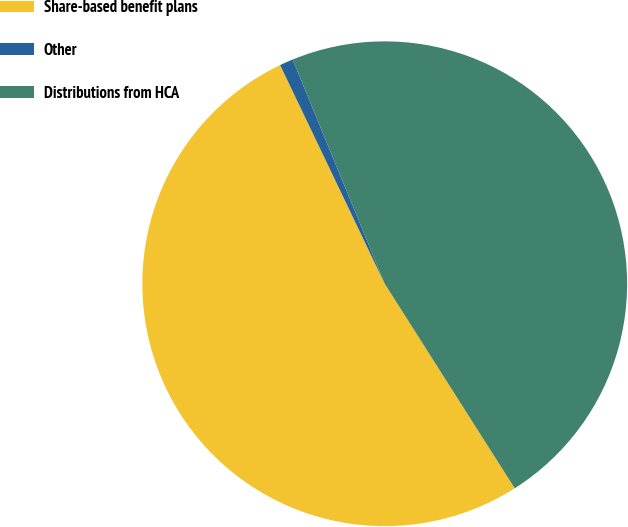Convert chart. <chart><loc_0><loc_0><loc_500><loc_500><pie_chart><fcel>Share-based benefit plans<fcel>Other<fcel>Distributions from HCA<nl><fcel>51.91%<fcel>0.9%<fcel>47.19%<nl></chart> 